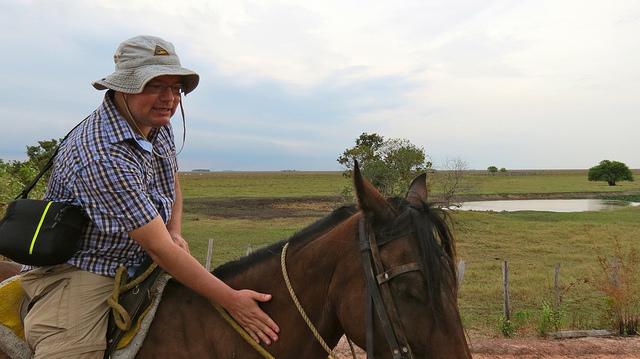What is the man riding?
Short answer required. Horse. Is this a winter scene?
Be succinct. No. Is the man young or old?
Short answer required. Old. Does the man look like he's having fun?
Be succinct. Yes. What are the people sitting on?
Give a very brief answer. Horse. What color is the man's backpack?
Be succinct. Black. Does this man have plaid pants on?
Write a very short answer. No. Is the man wearing leather gloves?
Short answer required. No. 